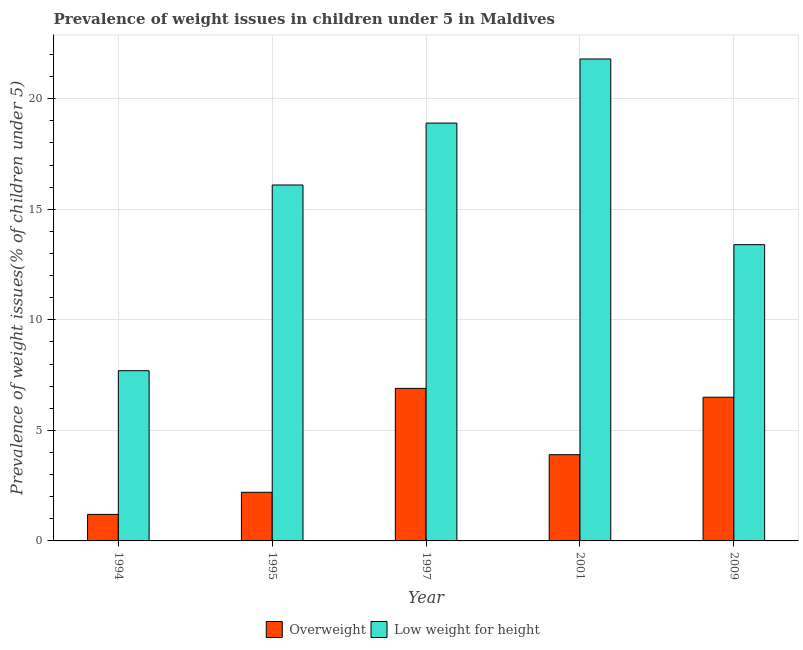How many different coloured bars are there?
Keep it short and to the point. 2. Are the number of bars on each tick of the X-axis equal?
Provide a succinct answer. Yes. In how many cases, is the number of bars for a given year not equal to the number of legend labels?
Ensure brevity in your answer.  0. What is the percentage of overweight children in 1997?
Ensure brevity in your answer.  6.9. Across all years, what is the maximum percentage of underweight children?
Keep it short and to the point. 21.8. Across all years, what is the minimum percentage of underweight children?
Your answer should be compact. 7.7. In which year was the percentage of underweight children maximum?
Your response must be concise. 2001. In which year was the percentage of underweight children minimum?
Keep it short and to the point. 1994. What is the total percentage of overweight children in the graph?
Give a very brief answer. 20.7. What is the difference between the percentage of overweight children in 1995 and that in 2001?
Ensure brevity in your answer.  -1.7. What is the difference between the percentage of underweight children in 1994 and the percentage of overweight children in 2001?
Your answer should be compact. -14.1. What is the average percentage of overweight children per year?
Offer a very short reply. 4.14. What is the ratio of the percentage of overweight children in 1997 to that in 2009?
Your response must be concise. 1.06. Is the difference between the percentage of overweight children in 1997 and 2009 greater than the difference between the percentage of underweight children in 1997 and 2009?
Offer a very short reply. No. What is the difference between the highest and the second highest percentage of underweight children?
Your answer should be very brief. 2.9. What is the difference between the highest and the lowest percentage of underweight children?
Provide a succinct answer. 14.1. In how many years, is the percentage of overweight children greater than the average percentage of overweight children taken over all years?
Offer a terse response. 2. Is the sum of the percentage of underweight children in 1994 and 1997 greater than the maximum percentage of overweight children across all years?
Keep it short and to the point. Yes. What does the 2nd bar from the left in 1997 represents?
Offer a terse response. Low weight for height. What does the 1st bar from the right in 1994 represents?
Offer a very short reply. Low weight for height. How many bars are there?
Make the answer very short. 10. Are all the bars in the graph horizontal?
Ensure brevity in your answer.  No. Are the values on the major ticks of Y-axis written in scientific E-notation?
Your response must be concise. No. Does the graph contain any zero values?
Provide a short and direct response. No. Does the graph contain grids?
Give a very brief answer. Yes. What is the title of the graph?
Your answer should be very brief. Prevalence of weight issues in children under 5 in Maldives. Does "Secondary education" appear as one of the legend labels in the graph?
Offer a terse response. No. What is the label or title of the Y-axis?
Provide a succinct answer. Prevalence of weight issues(% of children under 5). What is the Prevalence of weight issues(% of children under 5) of Overweight in 1994?
Your answer should be very brief. 1.2. What is the Prevalence of weight issues(% of children under 5) in Low weight for height in 1994?
Offer a terse response. 7.7. What is the Prevalence of weight issues(% of children under 5) of Overweight in 1995?
Make the answer very short. 2.2. What is the Prevalence of weight issues(% of children under 5) of Low weight for height in 1995?
Make the answer very short. 16.1. What is the Prevalence of weight issues(% of children under 5) in Overweight in 1997?
Your answer should be very brief. 6.9. What is the Prevalence of weight issues(% of children under 5) in Low weight for height in 1997?
Offer a very short reply. 18.9. What is the Prevalence of weight issues(% of children under 5) of Overweight in 2001?
Your answer should be very brief. 3.9. What is the Prevalence of weight issues(% of children under 5) of Low weight for height in 2001?
Offer a very short reply. 21.8. What is the Prevalence of weight issues(% of children under 5) of Overweight in 2009?
Your answer should be very brief. 6.5. What is the Prevalence of weight issues(% of children under 5) of Low weight for height in 2009?
Offer a terse response. 13.4. Across all years, what is the maximum Prevalence of weight issues(% of children under 5) of Overweight?
Your answer should be compact. 6.9. Across all years, what is the maximum Prevalence of weight issues(% of children under 5) in Low weight for height?
Your response must be concise. 21.8. Across all years, what is the minimum Prevalence of weight issues(% of children under 5) of Overweight?
Your answer should be compact. 1.2. Across all years, what is the minimum Prevalence of weight issues(% of children under 5) in Low weight for height?
Provide a succinct answer. 7.7. What is the total Prevalence of weight issues(% of children under 5) in Overweight in the graph?
Keep it short and to the point. 20.7. What is the total Prevalence of weight issues(% of children under 5) of Low weight for height in the graph?
Offer a terse response. 77.9. What is the difference between the Prevalence of weight issues(% of children under 5) of Overweight in 1994 and that in 1997?
Make the answer very short. -5.7. What is the difference between the Prevalence of weight issues(% of children under 5) in Overweight in 1994 and that in 2001?
Ensure brevity in your answer.  -2.7. What is the difference between the Prevalence of weight issues(% of children under 5) of Low weight for height in 1994 and that in 2001?
Your answer should be compact. -14.1. What is the difference between the Prevalence of weight issues(% of children under 5) of Low weight for height in 1994 and that in 2009?
Your answer should be very brief. -5.7. What is the difference between the Prevalence of weight issues(% of children under 5) of Overweight in 1995 and that in 1997?
Provide a succinct answer. -4.7. What is the difference between the Prevalence of weight issues(% of children under 5) of Low weight for height in 1995 and that in 1997?
Keep it short and to the point. -2.8. What is the difference between the Prevalence of weight issues(% of children under 5) in Overweight in 1995 and that in 2001?
Ensure brevity in your answer.  -1.7. What is the difference between the Prevalence of weight issues(% of children under 5) in Overweight in 1995 and that in 2009?
Offer a terse response. -4.3. What is the difference between the Prevalence of weight issues(% of children under 5) in Overweight in 1997 and that in 2009?
Offer a terse response. 0.4. What is the difference between the Prevalence of weight issues(% of children under 5) in Low weight for height in 1997 and that in 2009?
Provide a short and direct response. 5.5. What is the difference between the Prevalence of weight issues(% of children under 5) of Overweight in 2001 and that in 2009?
Provide a succinct answer. -2.6. What is the difference between the Prevalence of weight issues(% of children under 5) of Overweight in 1994 and the Prevalence of weight issues(% of children under 5) of Low weight for height in 1995?
Provide a short and direct response. -14.9. What is the difference between the Prevalence of weight issues(% of children under 5) of Overweight in 1994 and the Prevalence of weight issues(% of children under 5) of Low weight for height in 1997?
Offer a very short reply. -17.7. What is the difference between the Prevalence of weight issues(% of children under 5) of Overweight in 1994 and the Prevalence of weight issues(% of children under 5) of Low weight for height in 2001?
Give a very brief answer. -20.6. What is the difference between the Prevalence of weight issues(% of children under 5) in Overweight in 1994 and the Prevalence of weight issues(% of children under 5) in Low weight for height in 2009?
Offer a very short reply. -12.2. What is the difference between the Prevalence of weight issues(% of children under 5) of Overweight in 1995 and the Prevalence of weight issues(% of children under 5) of Low weight for height in 1997?
Your answer should be very brief. -16.7. What is the difference between the Prevalence of weight issues(% of children under 5) of Overweight in 1995 and the Prevalence of weight issues(% of children under 5) of Low weight for height in 2001?
Your answer should be compact. -19.6. What is the difference between the Prevalence of weight issues(% of children under 5) in Overweight in 1995 and the Prevalence of weight issues(% of children under 5) in Low weight for height in 2009?
Your answer should be compact. -11.2. What is the difference between the Prevalence of weight issues(% of children under 5) in Overweight in 1997 and the Prevalence of weight issues(% of children under 5) in Low weight for height in 2001?
Ensure brevity in your answer.  -14.9. What is the difference between the Prevalence of weight issues(% of children under 5) of Overweight in 1997 and the Prevalence of weight issues(% of children under 5) of Low weight for height in 2009?
Your answer should be compact. -6.5. What is the average Prevalence of weight issues(% of children under 5) in Overweight per year?
Provide a succinct answer. 4.14. What is the average Prevalence of weight issues(% of children under 5) of Low weight for height per year?
Your answer should be very brief. 15.58. In the year 1994, what is the difference between the Prevalence of weight issues(% of children under 5) in Overweight and Prevalence of weight issues(% of children under 5) in Low weight for height?
Keep it short and to the point. -6.5. In the year 2001, what is the difference between the Prevalence of weight issues(% of children under 5) in Overweight and Prevalence of weight issues(% of children under 5) in Low weight for height?
Make the answer very short. -17.9. In the year 2009, what is the difference between the Prevalence of weight issues(% of children under 5) of Overweight and Prevalence of weight issues(% of children under 5) of Low weight for height?
Offer a terse response. -6.9. What is the ratio of the Prevalence of weight issues(% of children under 5) in Overweight in 1994 to that in 1995?
Ensure brevity in your answer.  0.55. What is the ratio of the Prevalence of weight issues(% of children under 5) in Low weight for height in 1994 to that in 1995?
Make the answer very short. 0.48. What is the ratio of the Prevalence of weight issues(% of children under 5) in Overweight in 1994 to that in 1997?
Make the answer very short. 0.17. What is the ratio of the Prevalence of weight issues(% of children under 5) in Low weight for height in 1994 to that in 1997?
Your answer should be compact. 0.41. What is the ratio of the Prevalence of weight issues(% of children under 5) in Overweight in 1994 to that in 2001?
Offer a terse response. 0.31. What is the ratio of the Prevalence of weight issues(% of children under 5) in Low weight for height in 1994 to that in 2001?
Provide a short and direct response. 0.35. What is the ratio of the Prevalence of weight issues(% of children under 5) in Overweight in 1994 to that in 2009?
Make the answer very short. 0.18. What is the ratio of the Prevalence of weight issues(% of children under 5) of Low weight for height in 1994 to that in 2009?
Your response must be concise. 0.57. What is the ratio of the Prevalence of weight issues(% of children under 5) in Overweight in 1995 to that in 1997?
Your answer should be very brief. 0.32. What is the ratio of the Prevalence of weight issues(% of children under 5) in Low weight for height in 1995 to that in 1997?
Offer a terse response. 0.85. What is the ratio of the Prevalence of weight issues(% of children under 5) of Overweight in 1995 to that in 2001?
Your answer should be very brief. 0.56. What is the ratio of the Prevalence of weight issues(% of children under 5) in Low weight for height in 1995 to that in 2001?
Provide a succinct answer. 0.74. What is the ratio of the Prevalence of weight issues(% of children under 5) of Overweight in 1995 to that in 2009?
Offer a very short reply. 0.34. What is the ratio of the Prevalence of weight issues(% of children under 5) in Low weight for height in 1995 to that in 2009?
Ensure brevity in your answer.  1.2. What is the ratio of the Prevalence of weight issues(% of children under 5) of Overweight in 1997 to that in 2001?
Give a very brief answer. 1.77. What is the ratio of the Prevalence of weight issues(% of children under 5) of Low weight for height in 1997 to that in 2001?
Keep it short and to the point. 0.87. What is the ratio of the Prevalence of weight issues(% of children under 5) of Overweight in 1997 to that in 2009?
Keep it short and to the point. 1.06. What is the ratio of the Prevalence of weight issues(% of children under 5) of Low weight for height in 1997 to that in 2009?
Your answer should be very brief. 1.41. What is the ratio of the Prevalence of weight issues(% of children under 5) in Low weight for height in 2001 to that in 2009?
Provide a succinct answer. 1.63. What is the difference between the highest and the lowest Prevalence of weight issues(% of children under 5) of Overweight?
Your response must be concise. 5.7. What is the difference between the highest and the lowest Prevalence of weight issues(% of children under 5) in Low weight for height?
Offer a very short reply. 14.1. 